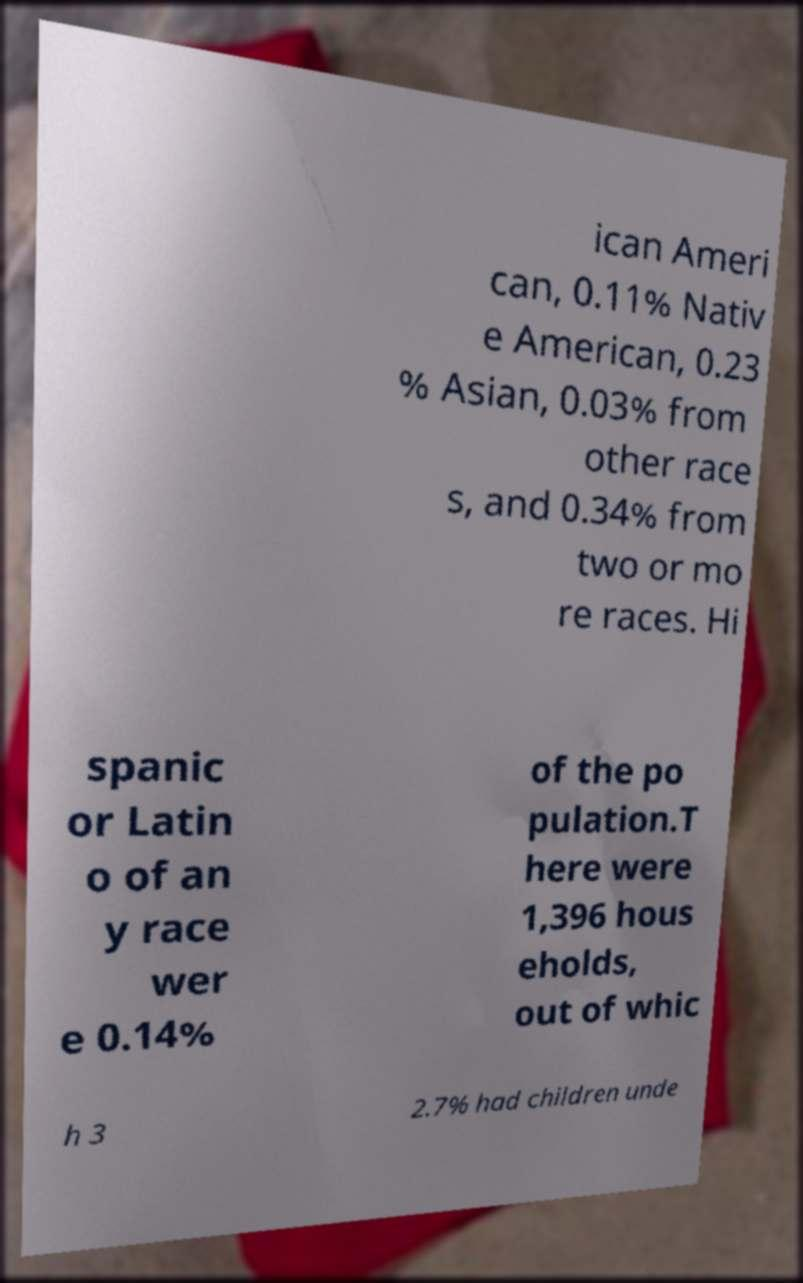For documentation purposes, I need the text within this image transcribed. Could you provide that? ican Ameri can, 0.11% Nativ e American, 0.23 % Asian, 0.03% from other race s, and 0.34% from two or mo re races. Hi spanic or Latin o of an y race wer e 0.14% of the po pulation.T here were 1,396 hous eholds, out of whic h 3 2.7% had children unde 